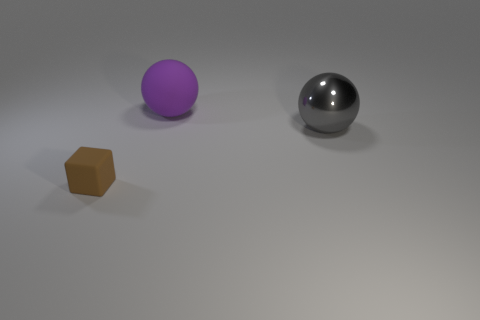Add 3 large shiny objects. How many objects exist? 6 Subtract all spheres. How many objects are left? 1 Add 3 matte things. How many matte things exist? 5 Subtract 0 gray blocks. How many objects are left? 3 Subtract all gray metal things. Subtract all brown matte blocks. How many objects are left? 1 Add 1 large purple things. How many large purple things are left? 2 